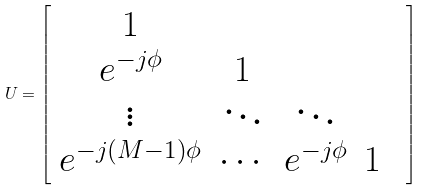Convert formula to latex. <formula><loc_0><loc_0><loc_500><loc_500>U = \left [ { \begin{array} { c c c c c } 1 & & & & \\ e ^ { - j \phi } & 1 & & & \\ \vdots & \ddots & \ddots & & \\ e ^ { - j \left ( M - 1 \right ) \phi } & \cdots & e ^ { - j \phi } & 1 & \\ \end{array} } \right ]</formula> 